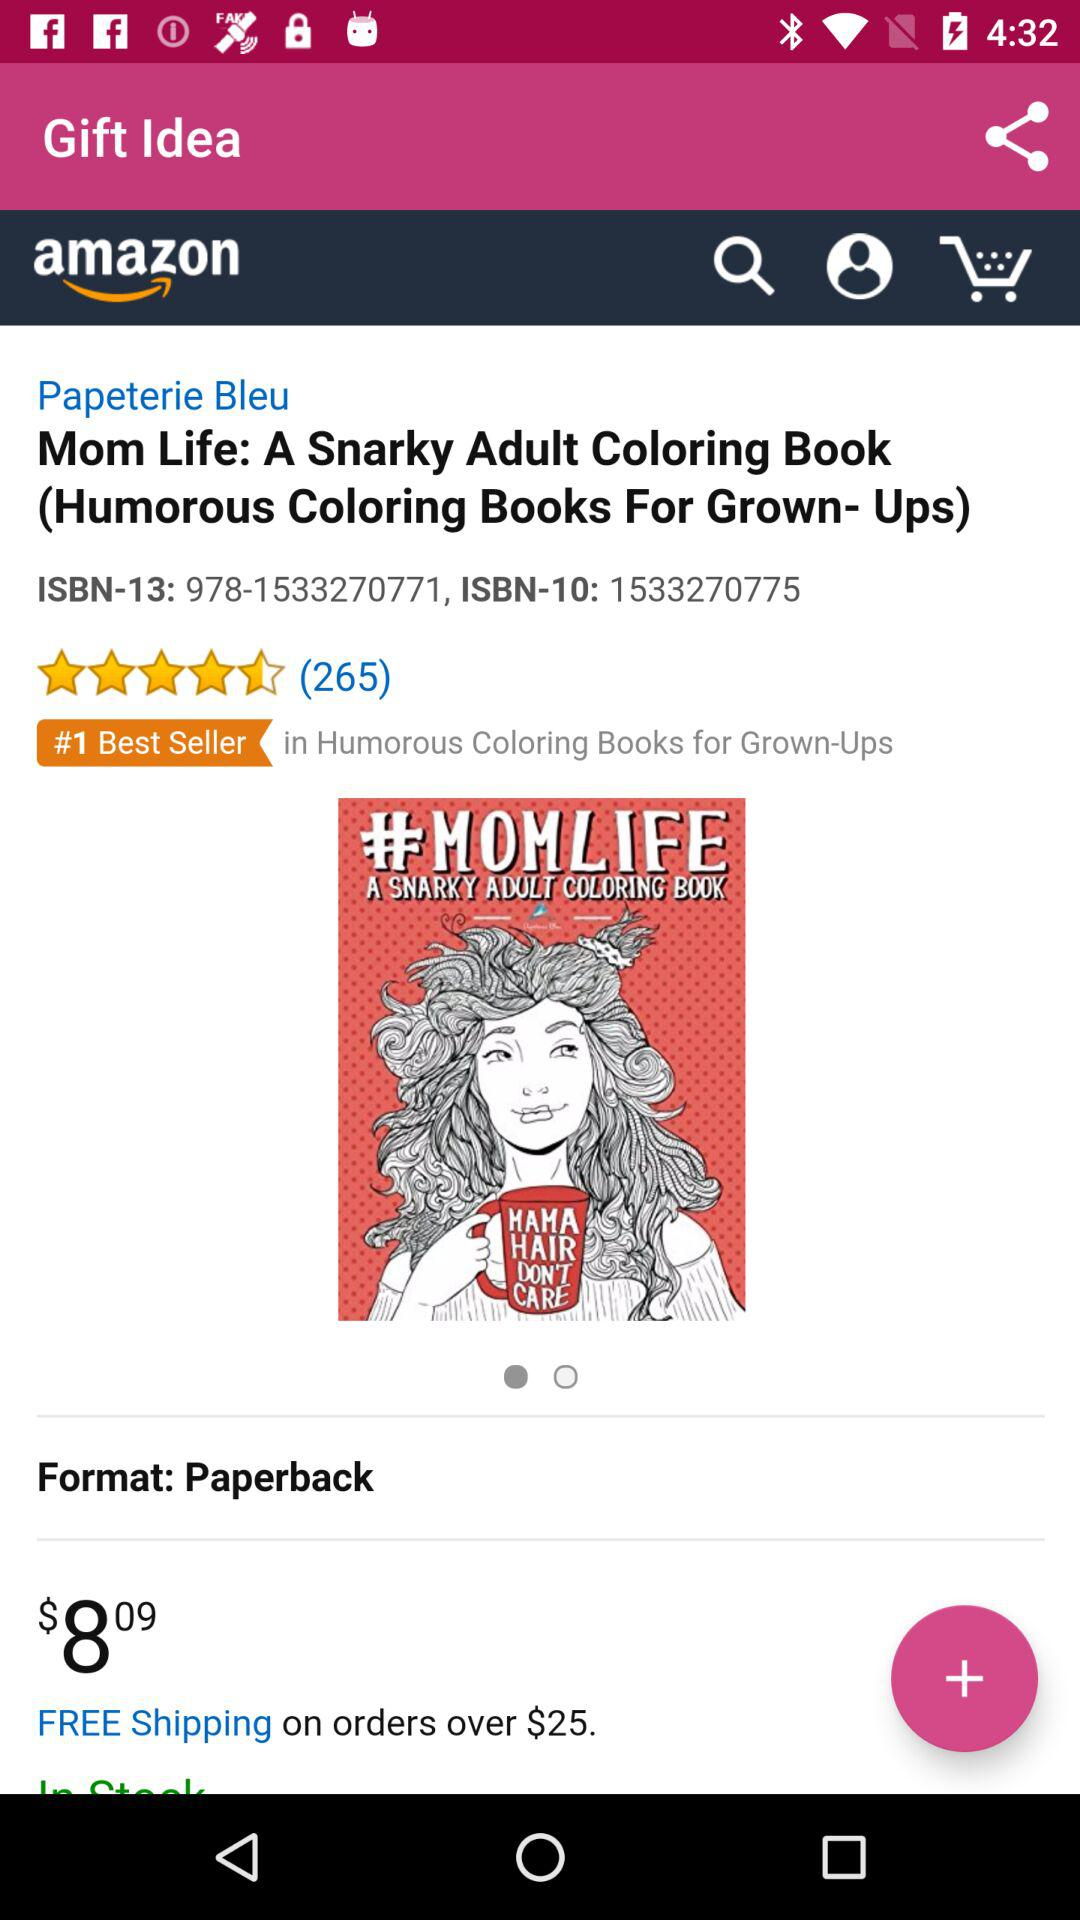What is the format of "Mom Life: A Snarky Adult Coloring Book"? The format is paperback. 